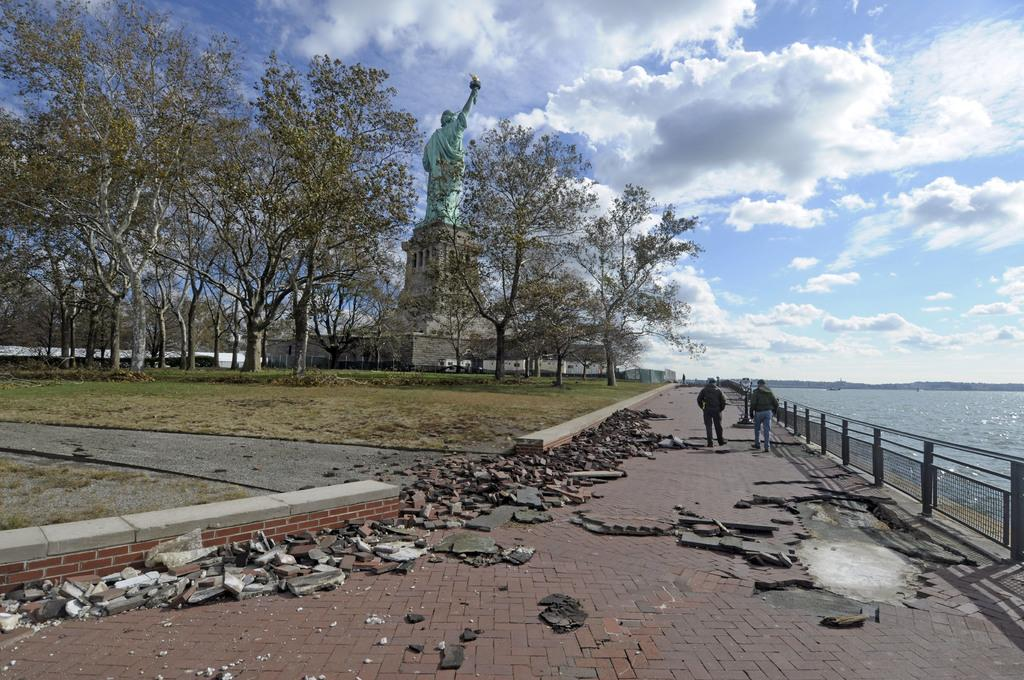How many persons are in the image? There are two persons in the image. What is the ground made of in the image? The ground is visible in the image, but the material is not specified. What type of vegetation is present in the image? Grass, plants, and trees are visible in the image. What is the statue made of in the image? The material of the statue is not specified in the image. What type of pathway is visible in the image? A road is visible in the image. What type of flooring is present in the image? Tiles are present in the image. What type of barrier is visible in the image? There is a fence in the image. What type of water feature is visible in the image? Water is visible in the image, but the type of water feature is not specified. What type of structures are present in the image? Buildings are present in the image. What is visible in the background of the image? The sky is visible in the background of the image, with clouds present. How many teeth can be seen on the train in the image? There is no train present in the image, so it is not possible to determine the number of teeth on a train. What type of fruit is being held by the pear in the image? There is no pear present in the image, so it is not possible to determine the type of fruit being held by a pear. 